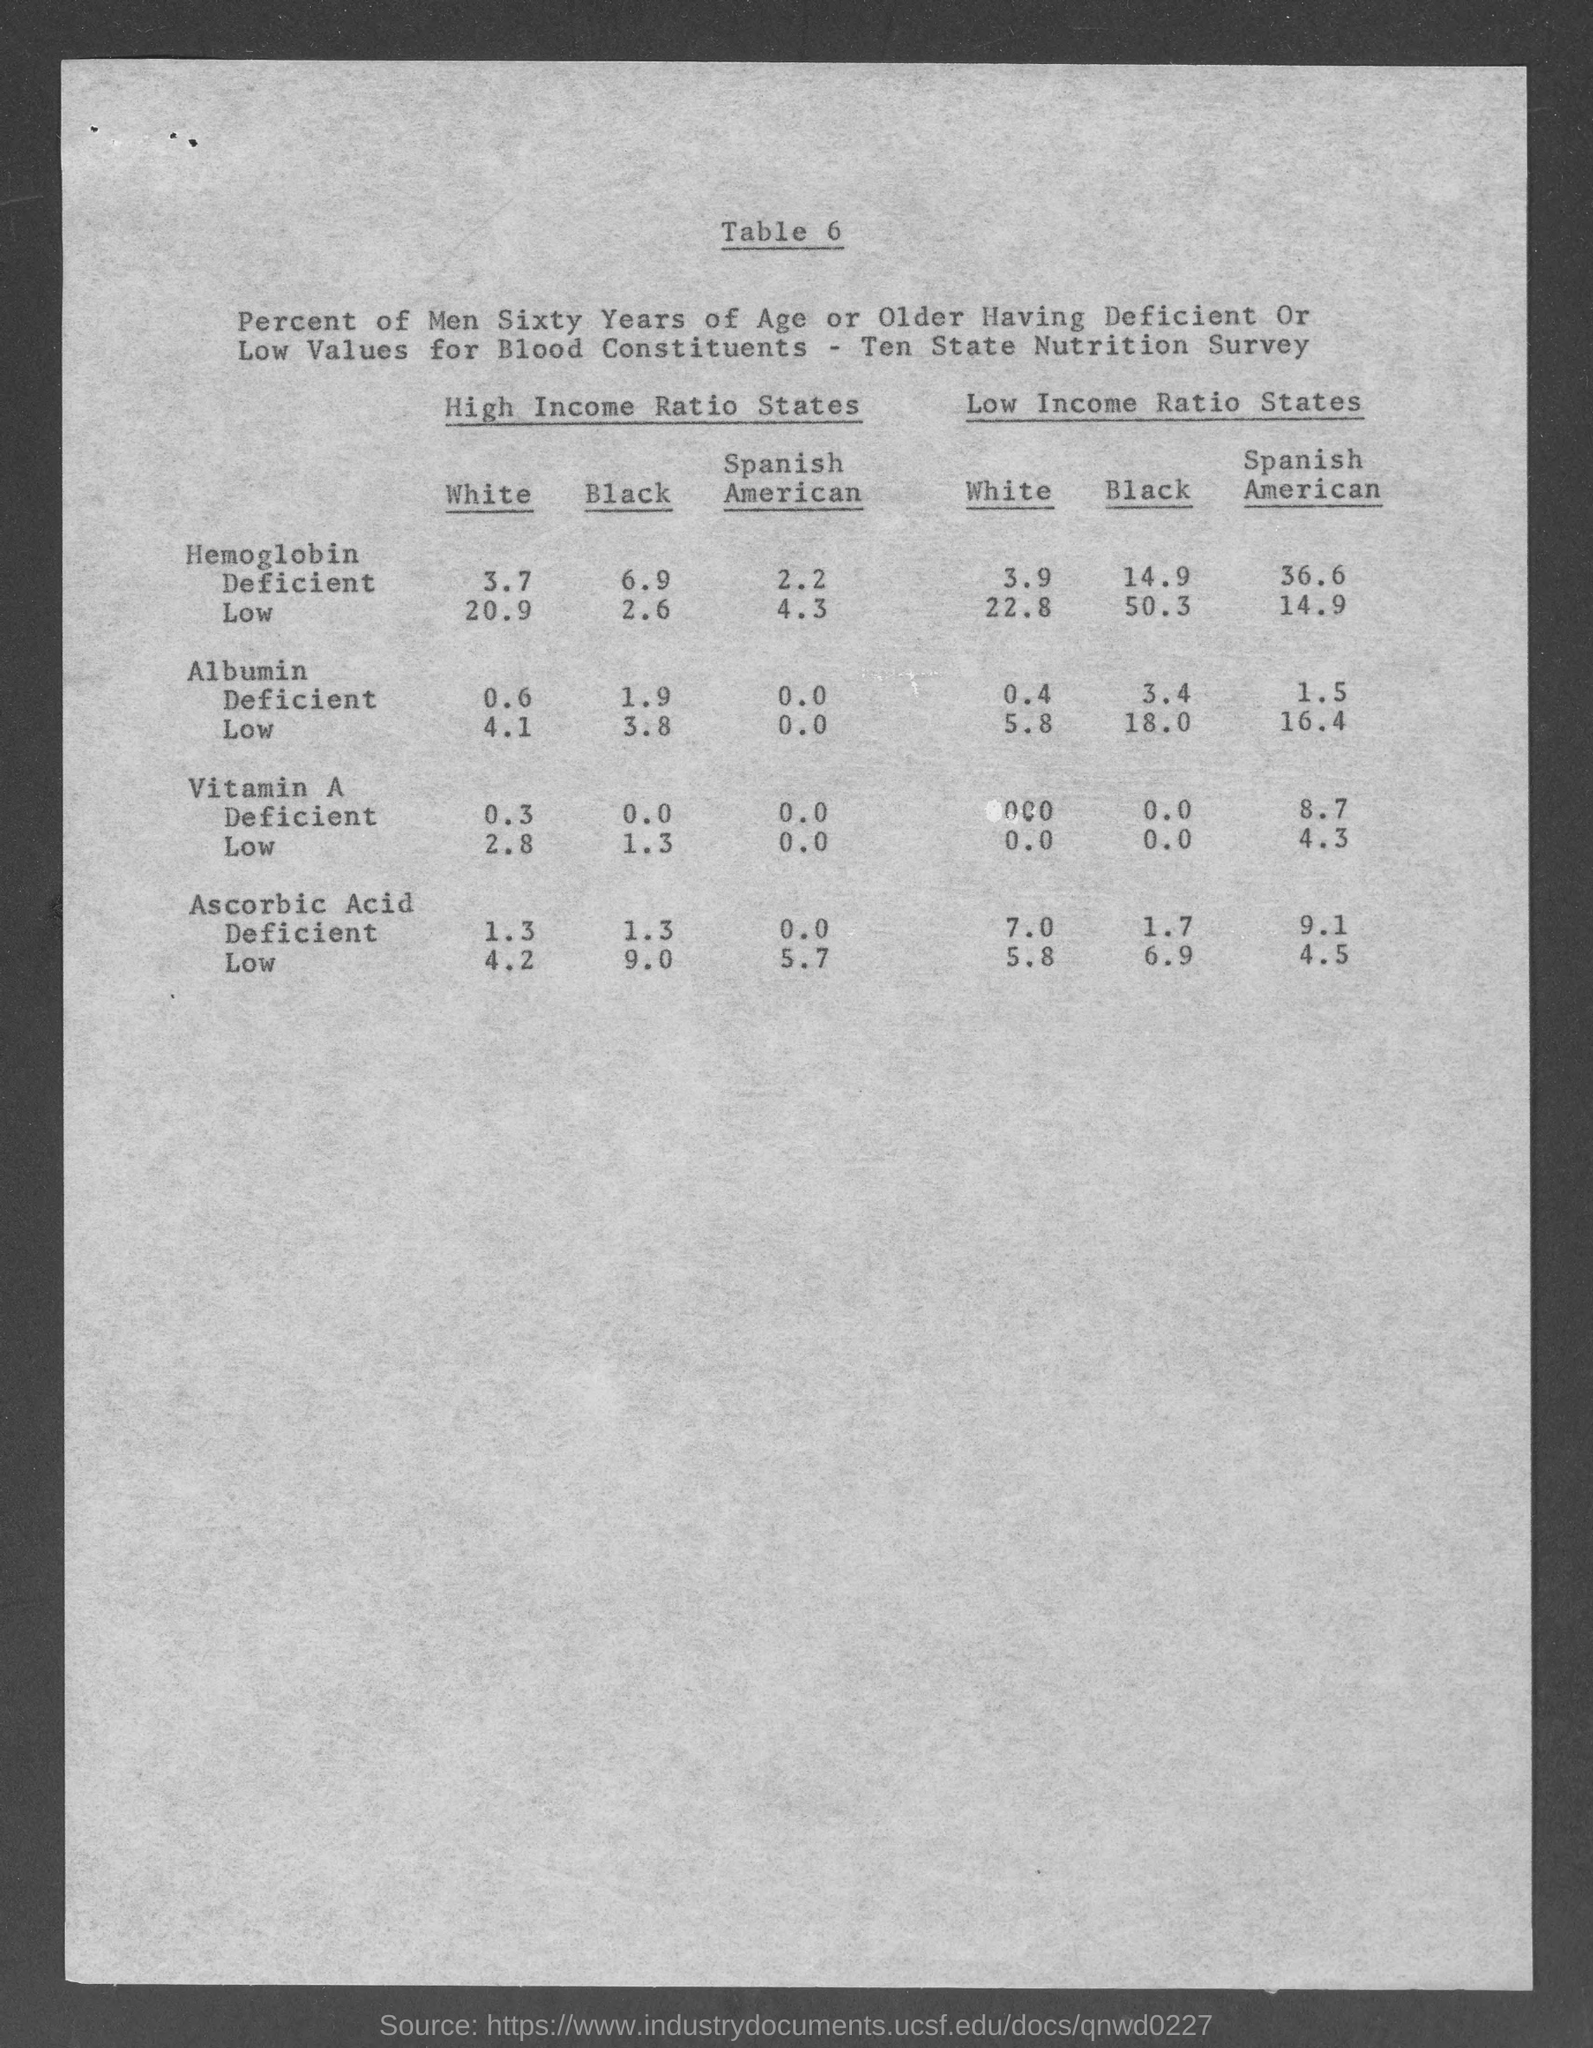What is the table number?
Give a very brief answer. Table 6. What is the percentage of white persons who are hemoglobin deficient in high-income ratio states?
Provide a succinct answer. 3.7. What is the percentage of black persons who are hemoglobin deficient in low-income ratio states?
Ensure brevity in your answer.  14.9. What is the percentage of white persons who are ascorbic acid-deficient in high-income ratio states?
Provide a short and direct response. 1.3. What is the percentage of black persons who are ascorbic acid-deficient in low-income ratio states?
Give a very brief answer. 1.7. What is the percentage of Spanish Americans who are low in Vitamin A in high-income ratio states?
Make the answer very short. 0.0. What is the percentage of Spanish Americans who are deficient in Vitamin A in low-income ratio states?
Give a very brief answer. 8.7. What is the percentage of Spanish Americans who are low in albumin in high-income ratio states?
Keep it short and to the point. 0.0. 